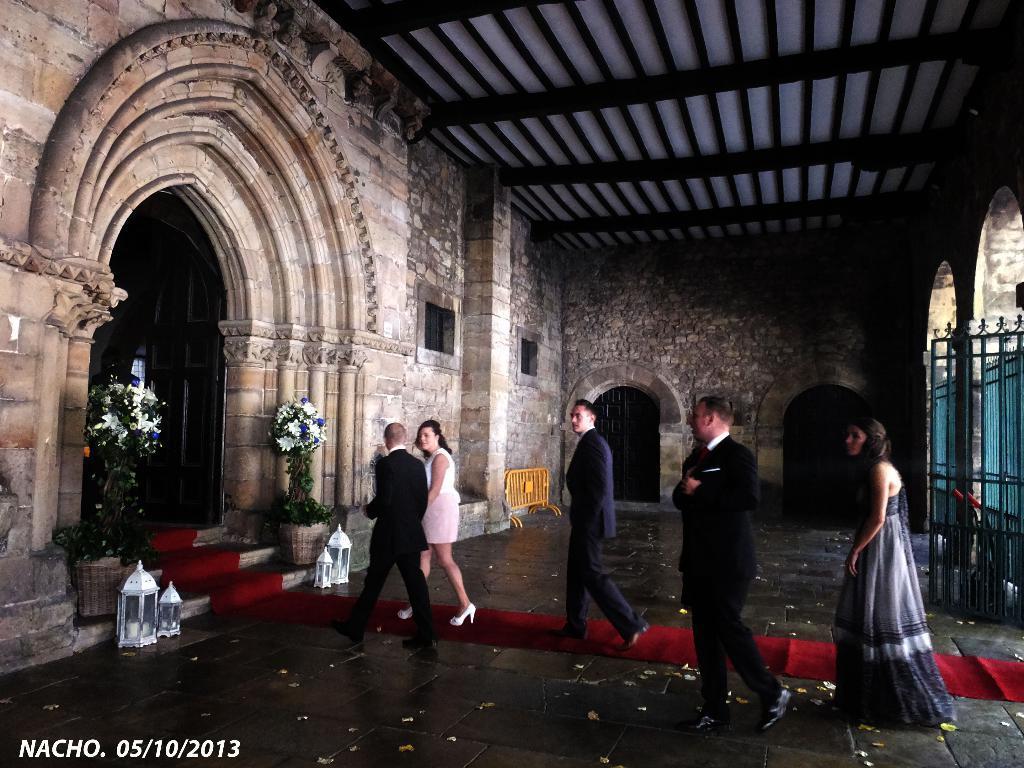Describe this image in one or two sentences. In the center of the image we can see people walking. On the left there is a door and we can see flower plants. There are decors. At the bottom there is a carpet. On the right there is a gate. 